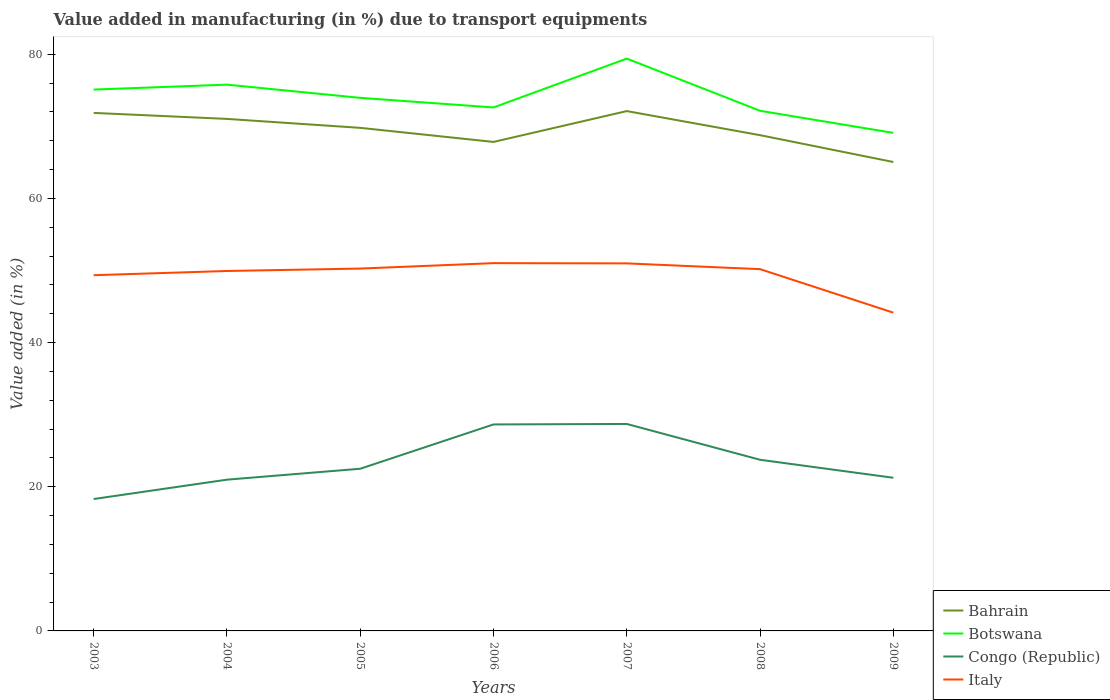Across all years, what is the maximum percentage of value added in manufacturing due to transport equipments in Bahrain?
Offer a terse response. 65.05. What is the total percentage of value added in manufacturing due to transport equipments in Botswana in the graph?
Offer a very short reply. 1.15. What is the difference between the highest and the second highest percentage of value added in manufacturing due to transport equipments in Italy?
Your response must be concise. 6.87. How many years are there in the graph?
Offer a very short reply. 7. Where does the legend appear in the graph?
Provide a short and direct response. Bottom right. How are the legend labels stacked?
Your response must be concise. Vertical. What is the title of the graph?
Provide a short and direct response. Value added in manufacturing (in %) due to transport equipments. What is the label or title of the X-axis?
Your answer should be very brief. Years. What is the label or title of the Y-axis?
Your answer should be very brief. Value added (in %). What is the Value added (in %) in Bahrain in 2003?
Provide a succinct answer. 71.86. What is the Value added (in %) in Botswana in 2003?
Provide a short and direct response. 75.1. What is the Value added (in %) in Congo (Republic) in 2003?
Offer a terse response. 18.3. What is the Value added (in %) of Italy in 2003?
Provide a succinct answer. 49.35. What is the Value added (in %) of Bahrain in 2004?
Your answer should be very brief. 71.03. What is the Value added (in %) in Botswana in 2004?
Your answer should be compact. 75.78. What is the Value added (in %) of Congo (Republic) in 2004?
Make the answer very short. 20.98. What is the Value added (in %) in Italy in 2004?
Give a very brief answer. 49.93. What is the Value added (in %) in Bahrain in 2005?
Your answer should be very brief. 69.79. What is the Value added (in %) in Botswana in 2005?
Ensure brevity in your answer.  73.95. What is the Value added (in %) in Congo (Republic) in 2005?
Make the answer very short. 22.5. What is the Value added (in %) of Italy in 2005?
Your answer should be very brief. 50.27. What is the Value added (in %) of Bahrain in 2006?
Make the answer very short. 67.84. What is the Value added (in %) of Botswana in 2006?
Your response must be concise. 72.62. What is the Value added (in %) of Congo (Republic) in 2006?
Provide a succinct answer. 28.64. What is the Value added (in %) of Italy in 2006?
Make the answer very short. 51.02. What is the Value added (in %) in Bahrain in 2007?
Provide a short and direct response. 72.11. What is the Value added (in %) of Botswana in 2007?
Offer a terse response. 79.39. What is the Value added (in %) in Congo (Republic) in 2007?
Offer a very short reply. 28.71. What is the Value added (in %) in Italy in 2007?
Your answer should be very brief. 50.99. What is the Value added (in %) in Bahrain in 2008?
Keep it short and to the point. 68.77. What is the Value added (in %) of Botswana in 2008?
Offer a terse response. 72.15. What is the Value added (in %) in Congo (Republic) in 2008?
Your answer should be very brief. 23.74. What is the Value added (in %) of Italy in 2008?
Provide a short and direct response. 50.19. What is the Value added (in %) in Bahrain in 2009?
Give a very brief answer. 65.05. What is the Value added (in %) in Botswana in 2009?
Your response must be concise. 69.09. What is the Value added (in %) in Congo (Republic) in 2009?
Your answer should be very brief. 21.24. What is the Value added (in %) in Italy in 2009?
Your response must be concise. 44.15. Across all years, what is the maximum Value added (in %) of Bahrain?
Keep it short and to the point. 72.11. Across all years, what is the maximum Value added (in %) in Botswana?
Offer a terse response. 79.39. Across all years, what is the maximum Value added (in %) of Congo (Republic)?
Your response must be concise. 28.71. Across all years, what is the maximum Value added (in %) in Italy?
Offer a terse response. 51.02. Across all years, what is the minimum Value added (in %) of Bahrain?
Your answer should be very brief. 65.05. Across all years, what is the minimum Value added (in %) in Botswana?
Make the answer very short. 69.09. Across all years, what is the minimum Value added (in %) in Congo (Republic)?
Make the answer very short. 18.3. Across all years, what is the minimum Value added (in %) in Italy?
Make the answer very short. 44.15. What is the total Value added (in %) of Bahrain in the graph?
Provide a succinct answer. 486.45. What is the total Value added (in %) of Botswana in the graph?
Your answer should be very brief. 518.08. What is the total Value added (in %) of Congo (Republic) in the graph?
Ensure brevity in your answer.  164.12. What is the total Value added (in %) in Italy in the graph?
Keep it short and to the point. 345.88. What is the difference between the Value added (in %) of Bahrain in 2003 and that in 2004?
Your answer should be compact. 0.83. What is the difference between the Value added (in %) of Botswana in 2003 and that in 2004?
Offer a very short reply. -0.68. What is the difference between the Value added (in %) in Congo (Republic) in 2003 and that in 2004?
Keep it short and to the point. -2.69. What is the difference between the Value added (in %) in Italy in 2003 and that in 2004?
Offer a very short reply. -0.58. What is the difference between the Value added (in %) in Bahrain in 2003 and that in 2005?
Provide a succinct answer. 2.07. What is the difference between the Value added (in %) of Botswana in 2003 and that in 2005?
Give a very brief answer. 1.15. What is the difference between the Value added (in %) in Congo (Republic) in 2003 and that in 2005?
Your response must be concise. -4.2. What is the difference between the Value added (in %) in Italy in 2003 and that in 2005?
Provide a succinct answer. -0.92. What is the difference between the Value added (in %) of Bahrain in 2003 and that in 2006?
Your answer should be compact. 4.03. What is the difference between the Value added (in %) in Botswana in 2003 and that in 2006?
Offer a terse response. 2.48. What is the difference between the Value added (in %) of Congo (Republic) in 2003 and that in 2006?
Provide a short and direct response. -10.35. What is the difference between the Value added (in %) of Italy in 2003 and that in 2006?
Keep it short and to the point. -1.67. What is the difference between the Value added (in %) of Bahrain in 2003 and that in 2007?
Offer a terse response. -0.25. What is the difference between the Value added (in %) of Botswana in 2003 and that in 2007?
Keep it short and to the point. -4.3. What is the difference between the Value added (in %) in Congo (Republic) in 2003 and that in 2007?
Offer a very short reply. -10.41. What is the difference between the Value added (in %) in Italy in 2003 and that in 2007?
Give a very brief answer. -1.64. What is the difference between the Value added (in %) of Bahrain in 2003 and that in 2008?
Your response must be concise. 3.09. What is the difference between the Value added (in %) in Botswana in 2003 and that in 2008?
Give a very brief answer. 2.94. What is the difference between the Value added (in %) of Congo (Republic) in 2003 and that in 2008?
Make the answer very short. -5.45. What is the difference between the Value added (in %) of Italy in 2003 and that in 2008?
Give a very brief answer. -0.84. What is the difference between the Value added (in %) of Bahrain in 2003 and that in 2009?
Provide a short and direct response. 6.81. What is the difference between the Value added (in %) in Botswana in 2003 and that in 2009?
Ensure brevity in your answer.  6.01. What is the difference between the Value added (in %) in Congo (Republic) in 2003 and that in 2009?
Offer a very short reply. -2.95. What is the difference between the Value added (in %) in Italy in 2003 and that in 2009?
Offer a very short reply. 5.2. What is the difference between the Value added (in %) of Bahrain in 2004 and that in 2005?
Offer a very short reply. 1.24. What is the difference between the Value added (in %) in Botswana in 2004 and that in 2005?
Offer a terse response. 1.83. What is the difference between the Value added (in %) of Congo (Republic) in 2004 and that in 2005?
Give a very brief answer. -1.51. What is the difference between the Value added (in %) of Italy in 2004 and that in 2005?
Your answer should be very brief. -0.33. What is the difference between the Value added (in %) of Bahrain in 2004 and that in 2006?
Your answer should be compact. 3.19. What is the difference between the Value added (in %) of Botswana in 2004 and that in 2006?
Your answer should be very brief. 3.17. What is the difference between the Value added (in %) in Congo (Republic) in 2004 and that in 2006?
Offer a terse response. -7.66. What is the difference between the Value added (in %) of Italy in 2004 and that in 2006?
Your response must be concise. -1.09. What is the difference between the Value added (in %) in Bahrain in 2004 and that in 2007?
Your answer should be compact. -1.08. What is the difference between the Value added (in %) in Botswana in 2004 and that in 2007?
Keep it short and to the point. -3.61. What is the difference between the Value added (in %) in Congo (Republic) in 2004 and that in 2007?
Provide a short and direct response. -7.73. What is the difference between the Value added (in %) in Italy in 2004 and that in 2007?
Your answer should be very brief. -1.05. What is the difference between the Value added (in %) in Bahrain in 2004 and that in 2008?
Your response must be concise. 2.26. What is the difference between the Value added (in %) of Botswana in 2004 and that in 2008?
Give a very brief answer. 3.63. What is the difference between the Value added (in %) of Congo (Republic) in 2004 and that in 2008?
Provide a succinct answer. -2.76. What is the difference between the Value added (in %) of Italy in 2004 and that in 2008?
Provide a succinct answer. -0.25. What is the difference between the Value added (in %) of Bahrain in 2004 and that in 2009?
Your answer should be compact. 5.98. What is the difference between the Value added (in %) in Botswana in 2004 and that in 2009?
Make the answer very short. 6.69. What is the difference between the Value added (in %) of Congo (Republic) in 2004 and that in 2009?
Provide a short and direct response. -0.26. What is the difference between the Value added (in %) of Italy in 2004 and that in 2009?
Your response must be concise. 5.78. What is the difference between the Value added (in %) of Bahrain in 2005 and that in 2006?
Give a very brief answer. 1.95. What is the difference between the Value added (in %) in Botswana in 2005 and that in 2006?
Provide a short and direct response. 1.33. What is the difference between the Value added (in %) in Congo (Republic) in 2005 and that in 2006?
Offer a very short reply. -6.15. What is the difference between the Value added (in %) in Italy in 2005 and that in 2006?
Offer a very short reply. -0.75. What is the difference between the Value added (in %) in Bahrain in 2005 and that in 2007?
Keep it short and to the point. -2.33. What is the difference between the Value added (in %) of Botswana in 2005 and that in 2007?
Your answer should be very brief. -5.45. What is the difference between the Value added (in %) in Congo (Republic) in 2005 and that in 2007?
Your response must be concise. -6.21. What is the difference between the Value added (in %) of Italy in 2005 and that in 2007?
Offer a terse response. -0.72. What is the difference between the Value added (in %) in Bahrain in 2005 and that in 2008?
Provide a short and direct response. 1.02. What is the difference between the Value added (in %) in Botswana in 2005 and that in 2008?
Provide a succinct answer. 1.8. What is the difference between the Value added (in %) of Congo (Republic) in 2005 and that in 2008?
Provide a short and direct response. -1.25. What is the difference between the Value added (in %) in Italy in 2005 and that in 2008?
Give a very brief answer. 0.08. What is the difference between the Value added (in %) of Bahrain in 2005 and that in 2009?
Provide a succinct answer. 4.74. What is the difference between the Value added (in %) of Botswana in 2005 and that in 2009?
Offer a terse response. 4.86. What is the difference between the Value added (in %) of Congo (Republic) in 2005 and that in 2009?
Provide a short and direct response. 1.25. What is the difference between the Value added (in %) in Italy in 2005 and that in 2009?
Provide a succinct answer. 6.12. What is the difference between the Value added (in %) of Bahrain in 2006 and that in 2007?
Your answer should be very brief. -4.28. What is the difference between the Value added (in %) of Botswana in 2006 and that in 2007?
Keep it short and to the point. -6.78. What is the difference between the Value added (in %) of Congo (Republic) in 2006 and that in 2007?
Keep it short and to the point. -0.07. What is the difference between the Value added (in %) in Italy in 2006 and that in 2007?
Offer a terse response. 0.03. What is the difference between the Value added (in %) of Bahrain in 2006 and that in 2008?
Offer a very short reply. -0.94. What is the difference between the Value added (in %) in Botswana in 2006 and that in 2008?
Make the answer very short. 0.46. What is the difference between the Value added (in %) in Congo (Republic) in 2006 and that in 2008?
Offer a terse response. 4.9. What is the difference between the Value added (in %) in Italy in 2006 and that in 2008?
Give a very brief answer. 0.83. What is the difference between the Value added (in %) in Bahrain in 2006 and that in 2009?
Give a very brief answer. 2.79. What is the difference between the Value added (in %) in Botswana in 2006 and that in 2009?
Make the answer very short. 3.53. What is the difference between the Value added (in %) of Congo (Republic) in 2006 and that in 2009?
Provide a succinct answer. 7.4. What is the difference between the Value added (in %) in Italy in 2006 and that in 2009?
Offer a terse response. 6.87. What is the difference between the Value added (in %) in Bahrain in 2007 and that in 2008?
Your response must be concise. 3.34. What is the difference between the Value added (in %) of Botswana in 2007 and that in 2008?
Give a very brief answer. 7.24. What is the difference between the Value added (in %) of Congo (Republic) in 2007 and that in 2008?
Your response must be concise. 4.97. What is the difference between the Value added (in %) in Italy in 2007 and that in 2008?
Offer a terse response. 0.8. What is the difference between the Value added (in %) in Bahrain in 2007 and that in 2009?
Provide a short and direct response. 7.06. What is the difference between the Value added (in %) in Botswana in 2007 and that in 2009?
Your answer should be very brief. 10.31. What is the difference between the Value added (in %) of Congo (Republic) in 2007 and that in 2009?
Your response must be concise. 7.47. What is the difference between the Value added (in %) in Italy in 2007 and that in 2009?
Ensure brevity in your answer.  6.83. What is the difference between the Value added (in %) in Bahrain in 2008 and that in 2009?
Offer a terse response. 3.72. What is the difference between the Value added (in %) in Botswana in 2008 and that in 2009?
Your answer should be compact. 3.07. What is the difference between the Value added (in %) of Congo (Republic) in 2008 and that in 2009?
Offer a very short reply. 2.5. What is the difference between the Value added (in %) of Italy in 2008 and that in 2009?
Keep it short and to the point. 6.04. What is the difference between the Value added (in %) in Bahrain in 2003 and the Value added (in %) in Botswana in 2004?
Your answer should be very brief. -3.92. What is the difference between the Value added (in %) in Bahrain in 2003 and the Value added (in %) in Congo (Republic) in 2004?
Your response must be concise. 50.88. What is the difference between the Value added (in %) of Bahrain in 2003 and the Value added (in %) of Italy in 2004?
Your response must be concise. 21.93. What is the difference between the Value added (in %) in Botswana in 2003 and the Value added (in %) in Congo (Republic) in 2004?
Offer a very short reply. 54.12. What is the difference between the Value added (in %) of Botswana in 2003 and the Value added (in %) of Italy in 2004?
Ensure brevity in your answer.  25.17. What is the difference between the Value added (in %) of Congo (Republic) in 2003 and the Value added (in %) of Italy in 2004?
Offer a terse response. -31.63. What is the difference between the Value added (in %) of Bahrain in 2003 and the Value added (in %) of Botswana in 2005?
Keep it short and to the point. -2.09. What is the difference between the Value added (in %) in Bahrain in 2003 and the Value added (in %) in Congo (Republic) in 2005?
Keep it short and to the point. 49.36. What is the difference between the Value added (in %) in Bahrain in 2003 and the Value added (in %) in Italy in 2005?
Ensure brevity in your answer.  21.59. What is the difference between the Value added (in %) of Botswana in 2003 and the Value added (in %) of Congo (Republic) in 2005?
Ensure brevity in your answer.  52.6. What is the difference between the Value added (in %) of Botswana in 2003 and the Value added (in %) of Italy in 2005?
Provide a succinct answer. 24.83. What is the difference between the Value added (in %) in Congo (Republic) in 2003 and the Value added (in %) in Italy in 2005?
Provide a short and direct response. -31.97. What is the difference between the Value added (in %) in Bahrain in 2003 and the Value added (in %) in Botswana in 2006?
Your response must be concise. -0.76. What is the difference between the Value added (in %) of Bahrain in 2003 and the Value added (in %) of Congo (Republic) in 2006?
Your response must be concise. 43.22. What is the difference between the Value added (in %) in Bahrain in 2003 and the Value added (in %) in Italy in 2006?
Make the answer very short. 20.84. What is the difference between the Value added (in %) of Botswana in 2003 and the Value added (in %) of Congo (Republic) in 2006?
Your answer should be very brief. 46.45. What is the difference between the Value added (in %) of Botswana in 2003 and the Value added (in %) of Italy in 2006?
Offer a terse response. 24.08. What is the difference between the Value added (in %) of Congo (Republic) in 2003 and the Value added (in %) of Italy in 2006?
Give a very brief answer. -32.72. What is the difference between the Value added (in %) of Bahrain in 2003 and the Value added (in %) of Botswana in 2007?
Provide a succinct answer. -7.53. What is the difference between the Value added (in %) of Bahrain in 2003 and the Value added (in %) of Congo (Republic) in 2007?
Keep it short and to the point. 43.15. What is the difference between the Value added (in %) in Bahrain in 2003 and the Value added (in %) in Italy in 2007?
Give a very brief answer. 20.87. What is the difference between the Value added (in %) in Botswana in 2003 and the Value added (in %) in Congo (Republic) in 2007?
Your answer should be very brief. 46.39. What is the difference between the Value added (in %) of Botswana in 2003 and the Value added (in %) of Italy in 2007?
Make the answer very short. 24.11. What is the difference between the Value added (in %) in Congo (Republic) in 2003 and the Value added (in %) in Italy in 2007?
Keep it short and to the point. -32.69. What is the difference between the Value added (in %) in Bahrain in 2003 and the Value added (in %) in Botswana in 2008?
Keep it short and to the point. -0.29. What is the difference between the Value added (in %) in Bahrain in 2003 and the Value added (in %) in Congo (Republic) in 2008?
Keep it short and to the point. 48.12. What is the difference between the Value added (in %) of Bahrain in 2003 and the Value added (in %) of Italy in 2008?
Your answer should be very brief. 21.67. What is the difference between the Value added (in %) of Botswana in 2003 and the Value added (in %) of Congo (Republic) in 2008?
Keep it short and to the point. 51.36. What is the difference between the Value added (in %) of Botswana in 2003 and the Value added (in %) of Italy in 2008?
Provide a succinct answer. 24.91. What is the difference between the Value added (in %) in Congo (Republic) in 2003 and the Value added (in %) in Italy in 2008?
Offer a terse response. -31.89. What is the difference between the Value added (in %) in Bahrain in 2003 and the Value added (in %) in Botswana in 2009?
Your answer should be very brief. 2.77. What is the difference between the Value added (in %) of Bahrain in 2003 and the Value added (in %) of Congo (Republic) in 2009?
Provide a succinct answer. 50.62. What is the difference between the Value added (in %) in Bahrain in 2003 and the Value added (in %) in Italy in 2009?
Provide a succinct answer. 27.71. What is the difference between the Value added (in %) of Botswana in 2003 and the Value added (in %) of Congo (Republic) in 2009?
Make the answer very short. 53.85. What is the difference between the Value added (in %) in Botswana in 2003 and the Value added (in %) in Italy in 2009?
Your answer should be very brief. 30.95. What is the difference between the Value added (in %) of Congo (Republic) in 2003 and the Value added (in %) of Italy in 2009?
Ensure brevity in your answer.  -25.85. What is the difference between the Value added (in %) of Bahrain in 2004 and the Value added (in %) of Botswana in 2005?
Your answer should be compact. -2.92. What is the difference between the Value added (in %) of Bahrain in 2004 and the Value added (in %) of Congo (Republic) in 2005?
Your answer should be compact. 48.53. What is the difference between the Value added (in %) in Bahrain in 2004 and the Value added (in %) in Italy in 2005?
Your answer should be very brief. 20.76. What is the difference between the Value added (in %) of Botswana in 2004 and the Value added (in %) of Congo (Republic) in 2005?
Your response must be concise. 53.28. What is the difference between the Value added (in %) of Botswana in 2004 and the Value added (in %) of Italy in 2005?
Provide a short and direct response. 25.52. What is the difference between the Value added (in %) in Congo (Republic) in 2004 and the Value added (in %) in Italy in 2005?
Provide a succinct answer. -29.28. What is the difference between the Value added (in %) of Bahrain in 2004 and the Value added (in %) of Botswana in 2006?
Keep it short and to the point. -1.59. What is the difference between the Value added (in %) in Bahrain in 2004 and the Value added (in %) in Congo (Republic) in 2006?
Make the answer very short. 42.38. What is the difference between the Value added (in %) in Bahrain in 2004 and the Value added (in %) in Italy in 2006?
Ensure brevity in your answer.  20.01. What is the difference between the Value added (in %) of Botswana in 2004 and the Value added (in %) of Congo (Republic) in 2006?
Provide a succinct answer. 47.14. What is the difference between the Value added (in %) of Botswana in 2004 and the Value added (in %) of Italy in 2006?
Ensure brevity in your answer.  24.76. What is the difference between the Value added (in %) in Congo (Republic) in 2004 and the Value added (in %) in Italy in 2006?
Your response must be concise. -30.04. What is the difference between the Value added (in %) of Bahrain in 2004 and the Value added (in %) of Botswana in 2007?
Provide a short and direct response. -8.37. What is the difference between the Value added (in %) of Bahrain in 2004 and the Value added (in %) of Congo (Republic) in 2007?
Your answer should be compact. 42.32. What is the difference between the Value added (in %) in Bahrain in 2004 and the Value added (in %) in Italy in 2007?
Keep it short and to the point. 20.04. What is the difference between the Value added (in %) of Botswana in 2004 and the Value added (in %) of Congo (Republic) in 2007?
Ensure brevity in your answer.  47.07. What is the difference between the Value added (in %) of Botswana in 2004 and the Value added (in %) of Italy in 2007?
Offer a very short reply. 24.8. What is the difference between the Value added (in %) of Congo (Republic) in 2004 and the Value added (in %) of Italy in 2007?
Ensure brevity in your answer.  -30. What is the difference between the Value added (in %) in Bahrain in 2004 and the Value added (in %) in Botswana in 2008?
Make the answer very short. -1.13. What is the difference between the Value added (in %) in Bahrain in 2004 and the Value added (in %) in Congo (Republic) in 2008?
Ensure brevity in your answer.  47.29. What is the difference between the Value added (in %) in Bahrain in 2004 and the Value added (in %) in Italy in 2008?
Make the answer very short. 20.84. What is the difference between the Value added (in %) of Botswana in 2004 and the Value added (in %) of Congo (Republic) in 2008?
Offer a terse response. 52.04. What is the difference between the Value added (in %) in Botswana in 2004 and the Value added (in %) in Italy in 2008?
Provide a succinct answer. 25.6. What is the difference between the Value added (in %) in Congo (Republic) in 2004 and the Value added (in %) in Italy in 2008?
Offer a terse response. -29.2. What is the difference between the Value added (in %) of Bahrain in 2004 and the Value added (in %) of Botswana in 2009?
Make the answer very short. 1.94. What is the difference between the Value added (in %) of Bahrain in 2004 and the Value added (in %) of Congo (Republic) in 2009?
Give a very brief answer. 49.78. What is the difference between the Value added (in %) of Bahrain in 2004 and the Value added (in %) of Italy in 2009?
Ensure brevity in your answer.  26.88. What is the difference between the Value added (in %) of Botswana in 2004 and the Value added (in %) of Congo (Republic) in 2009?
Ensure brevity in your answer.  54.54. What is the difference between the Value added (in %) of Botswana in 2004 and the Value added (in %) of Italy in 2009?
Offer a terse response. 31.63. What is the difference between the Value added (in %) in Congo (Republic) in 2004 and the Value added (in %) in Italy in 2009?
Your answer should be compact. -23.17. What is the difference between the Value added (in %) of Bahrain in 2005 and the Value added (in %) of Botswana in 2006?
Give a very brief answer. -2.83. What is the difference between the Value added (in %) of Bahrain in 2005 and the Value added (in %) of Congo (Republic) in 2006?
Your answer should be compact. 41.14. What is the difference between the Value added (in %) in Bahrain in 2005 and the Value added (in %) in Italy in 2006?
Give a very brief answer. 18.77. What is the difference between the Value added (in %) of Botswana in 2005 and the Value added (in %) of Congo (Republic) in 2006?
Give a very brief answer. 45.3. What is the difference between the Value added (in %) of Botswana in 2005 and the Value added (in %) of Italy in 2006?
Ensure brevity in your answer.  22.93. What is the difference between the Value added (in %) of Congo (Republic) in 2005 and the Value added (in %) of Italy in 2006?
Keep it short and to the point. -28.52. What is the difference between the Value added (in %) of Bahrain in 2005 and the Value added (in %) of Botswana in 2007?
Ensure brevity in your answer.  -9.61. What is the difference between the Value added (in %) in Bahrain in 2005 and the Value added (in %) in Congo (Republic) in 2007?
Make the answer very short. 41.08. What is the difference between the Value added (in %) of Bahrain in 2005 and the Value added (in %) of Italy in 2007?
Ensure brevity in your answer.  18.8. What is the difference between the Value added (in %) of Botswana in 2005 and the Value added (in %) of Congo (Republic) in 2007?
Your answer should be compact. 45.24. What is the difference between the Value added (in %) in Botswana in 2005 and the Value added (in %) in Italy in 2007?
Your response must be concise. 22.96. What is the difference between the Value added (in %) in Congo (Republic) in 2005 and the Value added (in %) in Italy in 2007?
Your answer should be very brief. -28.49. What is the difference between the Value added (in %) of Bahrain in 2005 and the Value added (in %) of Botswana in 2008?
Provide a short and direct response. -2.37. What is the difference between the Value added (in %) in Bahrain in 2005 and the Value added (in %) in Congo (Republic) in 2008?
Provide a succinct answer. 46.04. What is the difference between the Value added (in %) in Bahrain in 2005 and the Value added (in %) in Italy in 2008?
Make the answer very short. 19.6. What is the difference between the Value added (in %) of Botswana in 2005 and the Value added (in %) of Congo (Republic) in 2008?
Offer a terse response. 50.21. What is the difference between the Value added (in %) in Botswana in 2005 and the Value added (in %) in Italy in 2008?
Make the answer very short. 23.76. What is the difference between the Value added (in %) in Congo (Republic) in 2005 and the Value added (in %) in Italy in 2008?
Offer a terse response. -27.69. What is the difference between the Value added (in %) in Bahrain in 2005 and the Value added (in %) in Botswana in 2009?
Give a very brief answer. 0.7. What is the difference between the Value added (in %) in Bahrain in 2005 and the Value added (in %) in Congo (Republic) in 2009?
Give a very brief answer. 48.54. What is the difference between the Value added (in %) in Bahrain in 2005 and the Value added (in %) in Italy in 2009?
Keep it short and to the point. 25.64. What is the difference between the Value added (in %) of Botswana in 2005 and the Value added (in %) of Congo (Republic) in 2009?
Your answer should be very brief. 52.7. What is the difference between the Value added (in %) of Botswana in 2005 and the Value added (in %) of Italy in 2009?
Make the answer very short. 29.8. What is the difference between the Value added (in %) in Congo (Republic) in 2005 and the Value added (in %) in Italy in 2009?
Offer a very short reply. -21.65. What is the difference between the Value added (in %) in Bahrain in 2006 and the Value added (in %) in Botswana in 2007?
Your answer should be compact. -11.56. What is the difference between the Value added (in %) in Bahrain in 2006 and the Value added (in %) in Congo (Republic) in 2007?
Your answer should be compact. 39.12. What is the difference between the Value added (in %) in Bahrain in 2006 and the Value added (in %) in Italy in 2007?
Offer a very short reply. 16.85. What is the difference between the Value added (in %) of Botswana in 2006 and the Value added (in %) of Congo (Republic) in 2007?
Ensure brevity in your answer.  43.91. What is the difference between the Value added (in %) of Botswana in 2006 and the Value added (in %) of Italy in 2007?
Your response must be concise. 21.63. What is the difference between the Value added (in %) of Congo (Republic) in 2006 and the Value added (in %) of Italy in 2007?
Ensure brevity in your answer.  -22.34. What is the difference between the Value added (in %) of Bahrain in 2006 and the Value added (in %) of Botswana in 2008?
Offer a very short reply. -4.32. What is the difference between the Value added (in %) of Bahrain in 2006 and the Value added (in %) of Congo (Republic) in 2008?
Provide a short and direct response. 44.09. What is the difference between the Value added (in %) in Bahrain in 2006 and the Value added (in %) in Italy in 2008?
Provide a succinct answer. 17.65. What is the difference between the Value added (in %) in Botswana in 2006 and the Value added (in %) in Congo (Republic) in 2008?
Provide a short and direct response. 48.87. What is the difference between the Value added (in %) in Botswana in 2006 and the Value added (in %) in Italy in 2008?
Offer a very short reply. 22.43. What is the difference between the Value added (in %) in Congo (Republic) in 2006 and the Value added (in %) in Italy in 2008?
Ensure brevity in your answer.  -21.54. What is the difference between the Value added (in %) of Bahrain in 2006 and the Value added (in %) of Botswana in 2009?
Your answer should be compact. -1.25. What is the difference between the Value added (in %) in Bahrain in 2006 and the Value added (in %) in Congo (Republic) in 2009?
Ensure brevity in your answer.  46.59. What is the difference between the Value added (in %) of Bahrain in 2006 and the Value added (in %) of Italy in 2009?
Provide a short and direct response. 23.68. What is the difference between the Value added (in %) in Botswana in 2006 and the Value added (in %) in Congo (Republic) in 2009?
Ensure brevity in your answer.  51.37. What is the difference between the Value added (in %) of Botswana in 2006 and the Value added (in %) of Italy in 2009?
Your response must be concise. 28.47. What is the difference between the Value added (in %) of Congo (Republic) in 2006 and the Value added (in %) of Italy in 2009?
Provide a succinct answer. -15.51. What is the difference between the Value added (in %) in Bahrain in 2007 and the Value added (in %) in Botswana in 2008?
Your answer should be very brief. -0.04. What is the difference between the Value added (in %) in Bahrain in 2007 and the Value added (in %) in Congo (Republic) in 2008?
Keep it short and to the point. 48.37. What is the difference between the Value added (in %) in Bahrain in 2007 and the Value added (in %) in Italy in 2008?
Ensure brevity in your answer.  21.93. What is the difference between the Value added (in %) of Botswana in 2007 and the Value added (in %) of Congo (Republic) in 2008?
Offer a terse response. 55.65. What is the difference between the Value added (in %) in Botswana in 2007 and the Value added (in %) in Italy in 2008?
Offer a very short reply. 29.21. What is the difference between the Value added (in %) in Congo (Republic) in 2007 and the Value added (in %) in Italy in 2008?
Ensure brevity in your answer.  -21.48. What is the difference between the Value added (in %) of Bahrain in 2007 and the Value added (in %) of Botswana in 2009?
Ensure brevity in your answer.  3.02. What is the difference between the Value added (in %) of Bahrain in 2007 and the Value added (in %) of Congo (Republic) in 2009?
Make the answer very short. 50.87. What is the difference between the Value added (in %) of Bahrain in 2007 and the Value added (in %) of Italy in 2009?
Keep it short and to the point. 27.96. What is the difference between the Value added (in %) of Botswana in 2007 and the Value added (in %) of Congo (Republic) in 2009?
Your response must be concise. 58.15. What is the difference between the Value added (in %) of Botswana in 2007 and the Value added (in %) of Italy in 2009?
Ensure brevity in your answer.  35.24. What is the difference between the Value added (in %) of Congo (Republic) in 2007 and the Value added (in %) of Italy in 2009?
Your answer should be very brief. -15.44. What is the difference between the Value added (in %) in Bahrain in 2008 and the Value added (in %) in Botswana in 2009?
Provide a succinct answer. -0.32. What is the difference between the Value added (in %) of Bahrain in 2008 and the Value added (in %) of Congo (Republic) in 2009?
Provide a short and direct response. 47.53. What is the difference between the Value added (in %) in Bahrain in 2008 and the Value added (in %) in Italy in 2009?
Your answer should be very brief. 24.62. What is the difference between the Value added (in %) of Botswana in 2008 and the Value added (in %) of Congo (Republic) in 2009?
Provide a short and direct response. 50.91. What is the difference between the Value added (in %) in Botswana in 2008 and the Value added (in %) in Italy in 2009?
Provide a short and direct response. 28. What is the difference between the Value added (in %) in Congo (Republic) in 2008 and the Value added (in %) in Italy in 2009?
Make the answer very short. -20.41. What is the average Value added (in %) of Bahrain per year?
Your response must be concise. 69.49. What is the average Value added (in %) in Botswana per year?
Provide a short and direct response. 74.01. What is the average Value added (in %) in Congo (Republic) per year?
Your answer should be compact. 23.45. What is the average Value added (in %) in Italy per year?
Keep it short and to the point. 49.41. In the year 2003, what is the difference between the Value added (in %) of Bahrain and Value added (in %) of Botswana?
Your answer should be compact. -3.24. In the year 2003, what is the difference between the Value added (in %) in Bahrain and Value added (in %) in Congo (Republic)?
Give a very brief answer. 53.56. In the year 2003, what is the difference between the Value added (in %) of Bahrain and Value added (in %) of Italy?
Keep it short and to the point. 22.51. In the year 2003, what is the difference between the Value added (in %) in Botswana and Value added (in %) in Congo (Republic)?
Provide a succinct answer. 56.8. In the year 2003, what is the difference between the Value added (in %) of Botswana and Value added (in %) of Italy?
Make the answer very short. 25.75. In the year 2003, what is the difference between the Value added (in %) of Congo (Republic) and Value added (in %) of Italy?
Provide a short and direct response. -31.05. In the year 2004, what is the difference between the Value added (in %) in Bahrain and Value added (in %) in Botswana?
Offer a very short reply. -4.75. In the year 2004, what is the difference between the Value added (in %) of Bahrain and Value added (in %) of Congo (Republic)?
Offer a very short reply. 50.05. In the year 2004, what is the difference between the Value added (in %) in Bahrain and Value added (in %) in Italy?
Make the answer very short. 21.1. In the year 2004, what is the difference between the Value added (in %) in Botswana and Value added (in %) in Congo (Republic)?
Your answer should be very brief. 54.8. In the year 2004, what is the difference between the Value added (in %) in Botswana and Value added (in %) in Italy?
Provide a short and direct response. 25.85. In the year 2004, what is the difference between the Value added (in %) in Congo (Republic) and Value added (in %) in Italy?
Your response must be concise. -28.95. In the year 2005, what is the difference between the Value added (in %) of Bahrain and Value added (in %) of Botswana?
Provide a short and direct response. -4.16. In the year 2005, what is the difference between the Value added (in %) in Bahrain and Value added (in %) in Congo (Republic)?
Offer a terse response. 47.29. In the year 2005, what is the difference between the Value added (in %) of Bahrain and Value added (in %) of Italy?
Make the answer very short. 19.52. In the year 2005, what is the difference between the Value added (in %) of Botswana and Value added (in %) of Congo (Republic)?
Your answer should be very brief. 51.45. In the year 2005, what is the difference between the Value added (in %) in Botswana and Value added (in %) in Italy?
Make the answer very short. 23.68. In the year 2005, what is the difference between the Value added (in %) in Congo (Republic) and Value added (in %) in Italy?
Offer a terse response. -27.77. In the year 2006, what is the difference between the Value added (in %) of Bahrain and Value added (in %) of Botswana?
Your answer should be compact. -4.78. In the year 2006, what is the difference between the Value added (in %) of Bahrain and Value added (in %) of Congo (Republic)?
Keep it short and to the point. 39.19. In the year 2006, what is the difference between the Value added (in %) of Bahrain and Value added (in %) of Italy?
Offer a very short reply. 16.82. In the year 2006, what is the difference between the Value added (in %) in Botswana and Value added (in %) in Congo (Republic)?
Keep it short and to the point. 43.97. In the year 2006, what is the difference between the Value added (in %) in Botswana and Value added (in %) in Italy?
Offer a very short reply. 21.6. In the year 2006, what is the difference between the Value added (in %) in Congo (Republic) and Value added (in %) in Italy?
Your response must be concise. -22.37. In the year 2007, what is the difference between the Value added (in %) of Bahrain and Value added (in %) of Botswana?
Provide a succinct answer. -7.28. In the year 2007, what is the difference between the Value added (in %) in Bahrain and Value added (in %) in Congo (Republic)?
Your answer should be very brief. 43.4. In the year 2007, what is the difference between the Value added (in %) in Bahrain and Value added (in %) in Italy?
Make the answer very short. 21.13. In the year 2007, what is the difference between the Value added (in %) in Botswana and Value added (in %) in Congo (Republic)?
Offer a terse response. 50.68. In the year 2007, what is the difference between the Value added (in %) in Botswana and Value added (in %) in Italy?
Offer a terse response. 28.41. In the year 2007, what is the difference between the Value added (in %) in Congo (Republic) and Value added (in %) in Italy?
Ensure brevity in your answer.  -22.27. In the year 2008, what is the difference between the Value added (in %) in Bahrain and Value added (in %) in Botswana?
Ensure brevity in your answer.  -3.38. In the year 2008, what is the difference between the Value added (in %) of Bahrain and Value added (in %) of Congo (Republic)?
Your answer should be compact. 45.03. In the year 2008, what is the difference between the Value added (in %) in Bahrain and Value added (in %) in Italy?
Your answer should be compact. 18.59. In the year 2008, what is the difference between the Value added (in %) in Botswana and Value added (in %) in Congo (Republic)?
Offer a very short reply. 48.41. In the year 2008, what is the difference between the Value added (in %) of Botswana and Value added (in %) of Italy?
Provide a short and direct response. 21.97. In the year 2008, what is the difference between the Value added (in %) in Congo (Republic) and Value added (in %) in Italy?
Provide a short and direct response. -26.44. In the year 2009, what is the difference between the Value added (in %) of Bahrain and Value added (in %) of Botswana?
Offer a terse response. -4.04. In the year 2009, what is the difference between the Value added (in %) in Bahrain and Value added (in %) in Congo (Republic)?
Offer a very short reply. 43.8. In the year 2009, what is the difference between the Value added (in %) in Bahrain and Value added (in %) in Italy?
Your response must be concise. 20.9. In the year 2009, what is the difference between the Value added (in %) in Botswana and Value added (in %) in Congo (Republic)?
Give a very brief answer. 47.84. In the year 2009, what is the difference between the Value added (in %) of Botswana and Value added (in %) of Italy?
Your response must be concise. 24.94. In the year 2009, what is the difference between the Value added (in %) in Congo (Republic) and Value added (in %) in Italy?
Ensure brevity in your answer.  -22.91. What is the ratio of the Value added (in %) in Bahrain in 2003 to that in 2004?
Your answer should be very brief. 1.01. What is the ratio of the Value added (in %) in Congo (Republic) in 2003 to that in 2004?
Ensure brevity in your answer.  0.87. What is the ratio of the Value added (in %) in Italy in 2003 to that in 2004?
Make the answer very short. 0.99. What is the ratio of the Value added (in %) in Bahrain in 2003 to that in 2005?
Provide a short and direct response. 1.03. What is the ratio of the Value added (in %) in Botswana in 2003 to that in 2005?
Offer a terse response. 1.02. What is the ratio of the Value added (in %) in Congo (Republic) in 2003 to that in 2005?
Provide a succinct answer. 0.81. What is the ratio of the Value added (in %) of Italy in 2003 to that in 2005?
Give a very brief answer. 0.98. What is the ratio of the Value added (in %) of Bahrain in 2003 to that in 2006?
Ensure brevity in your answer.  1.06. What is the ratio of the Value added (in %) of Botswana in 2003 to that in 2006?
Ensure brevity in your answer.  1.03. What is the ratio of the Value added (in %) in Congo (Republic) in 2003 to that in 2006?
Your response must be concise. 0.64. What is the ratio of the Value added (in %) in Italy in 2003 to that in 2006?
Keep it short and to the point. 0.97. What is the ratio of the Value added (in %) of Botswana in 2003 to that in 2007?
Provide a short and direct response. 0.95. What is the ratio of the Value added (in %) in Congo (Republic) in 2003 to that in 2007?
Your answer should be very brief. 0.64. What is the ratio of the Value added (in %) in Italy in 2003 to that in 2007?
Offer a terse response. 0.97. What is the ratio of the Value added (in %) of Bahrain in 2003 to that in 2008?
Your answer should be compact. 1.04. What is the ratio of the Value added (in %) of Botswana in 2003 to that in 2008?
Your answer should be very brief. 1.04. What is the ratio of the Value added (in %) in Congo (Republic) in 2003 to that in 2008?
Make the answer very short. 0.77. What is the ratio of the Value added (in %) of Italy in 2003 to that in 2008?
Give a very brief answer. 0.98. What is the ratio of the Value added (in %) in Bahrain in 2003 to that in 2009?
Your answer should be very brief. 1.1. What is the ratio of the Value added (in %) in Botswana in 2003 to that in 2009?
Your answer should be very brief. 1.09. What is the ratio of the Value added (in %) of Congo (Republic) in 2003 to that in 2009?
Your answer should be compact. 0.86. What is the ratio of the Value added (in %) of Italy in 2003 to that in 2009?
Your answer should be compact. 1.12. What is the ratio of the Value added (in %) of Bahrain in 2004 to that in 2005?
Your answer should be compact. 1.02. What is the ratio of the Value added (in %) of Botswana in 2004 to that in 2005?
Keep it short and to the point. 1.02. What is the ratio of the Value added (in %) in Congo (Republic) in 2004 to that in 2005?
Your answer should be very brief. 0.93. What is the ratio of the Value added (in %) in Bahrain in 2004 to that in 2006?
Provide a short and direct response. 1.05. What is the ratio of the Value added (in %) in Botswana in 2004 to that in 2006?
Your answer should be very brief. 1.04. What is the ratio of the Value added (in %) of Congo (Republic) in 2004 to that in 2006?
Offer a very short reply. 0.73. What is the ratio of the Value added (in %) of Italy in 2004 to that in 2006?
Your response must be concise. 0.98. What is the ratio of the Value added (in %) in Botswana in 2004 to that in 2007?
Provide a short and direct response. 0.95. What is the ratio of the Value added (in %) of Congo (Republic) in 2004 to that in 2007?
Make the answer very short. 0.73. What is the ratio of the Value added (in %) in Italy in 2004 to that in 2007?
Offer a terse response. 0.98. What is the ratio of the Value added (in %) of Bahrain in 2004 to that in 2008?
Provide a short and direct response. 1.03. What is the ratio of the Value added (in %) in Botswana in 2004 to that in 2008?
Give a very brief answer. 1.05. What is the ratio of the Value added (in %) in Congo (Republic) in 2004 to that in 2008?
Offer a terse response. 0.88. What is the ratio of the Value added (in %) of Italy in 2004 to that in 2008?
Make the answer very short. 0.99. What is the ratio of the Value added (in %) in Bahrain in 2004 to that in 2009?
Offer a terse response. 1.09. What is the ratio of the Value added (in %) of Botswana in 2004 to that in 2009?
Provide a succinct answer. 1.1. What is the ratio of the Value added (in %) of Congo (Republic) in 2004 to that in 2009?
Give a very brief answer. 0.99. What is the ratio of the Value added (in %) of Italy in 2004 to that in 2009?
Provide a succinct answer. 1.13. What is the ratio of the Value added (in %) of Bahrain in 2005 to that in 2006?
Offer a very short reply. 1.03. What is the ratio of the Value added (in %) in Botswana in 2005 to that in 2006?
Your answer should be compact. 1.02. What is the ratio of the Value added (in %) in Congo (Republic) in 2005 to that in 2006?
Offer a very short reply. 0.79. What is the ratio of the Value added (in %) of Italy in 2005 to that in 2006?
Offer a terse response. 0.99. What is the ratio of the Value added (in %) in Botswana in 2005 to that in 2007?
Give a very brief answer. 0.93. What is the ratio of the Value added (in %) in Congo (Republic) in 2005 to that in 2007?
Provide a succinct answer. 0.78. What is the ratio of the Value added (in %) of Italy in 2005 to that in 2007?
Offer a terse response. 0.99. What is the ratio of the Value added (in %) in Bahrain in 2005 to that in 2008?
Give a very brief answer. 1.01. What is the ratio of the Value added (in %) in Botswana in 2005 to that in 2008?
Offer a very short reply. 1.02. What is the ratio of the Value added (in %) in Congo (Republic) in 2005 to that in 2008?
Your response must be concise. 0.95. What is the ratio of the Value added (in %) of Italy in 2005 to that in 2008?
Provide a succinct answer. 1. What is the ratio of the Value added (in %) in Bahrain in 2005 to that in 2009?
Your response must be concise. 1.07. What is the ratio of the Value added (in %) of Botswana in 2005 to that in 2009?
Ensure brevity in your answer.  1.07. What is the ratio of the Value added (in %) of Congo (Republic) in 2005 to that in 2009?
Provide a short and direct response. 1.06. What is the ratio of the Value added (in %) of Italy in 2005 to that in 2009?
Your answer should be very brief. 1.14. What is the ratio of the Value added (in %) of Bahrain in 2006 to that in 2007?
Provide a succinct answer. 0.94. What is the ratio of the Value added (in %) in Botswana in 2006 to that in 2007?
Provide a succinct answer. 0.91. What is the ratio of the Value added (in %) in Italy in 2006 to that in 2007?
Your answer should be very brief. 1. What is the ratio of the Value added (in %) in Bahrain in 2006 to that in 2008?
Provide a succinct answer. 0.99. What is the ratio of the Value added (in %) in Botswana in 2006 to that in 2008?
Your answer should be very brief. 1.01. What is the ratio of the Value added (in %) of Congo (Republic) in 2006 to that in 2008?
Your answer should be very brief. 1.21. What is the ratio of the Value added (in %) of Italy in 2006 to that in 2008?
Provide a short and direct response. 1.02. What is the ratio of the Value added (in %) in Bahrain in 2006 to that in 2009?
Your answer should be compact. 1.04. What is the ratio of the Value added (in %) of Botswana in 2006 to that in 2009?
Your answer should be compact. 1.05. What is the ratio of the Value added (in %) in Congo (Republic) in 2006 to that in 2009?
Give a very brief answer. 1.35. What is the ratio of the Value added (in %) in Italy in 2006 to that in 2009?
Provide a short and direct response. 1.16. What is the ratio of the Value added (in %) in Bahrain in 2007 to that in 2008?
Ensure brevity in your answer.  1.05. What is the ratio of the Value added (in %) of Botswana in 2007 to that in 2008?
Give a very brief answer. 1.1. What is the ratio of the Value added (in %) of Congo (Republic) in 2007 to that in 2008?
Your answer should be very brief. 1.21. What is the ratio of the Value added (in %) in Italy in 2007 to that in 2008?
Your answer should be very brief. 1.02. What is the ratio of the Value added (in %) in Bahrain in 2007 to that in 2009?
Keep it short and to the point. 1.11. What is the ratio of the Value added (in %) of Botswana in 2007 to that in 2009?
Your response must be concise. 1.15. What is the ratio of the Value added (in %) of Congo (Republic) in 2007 to that in 2009?
Your answer should be very brief. 1.35. What is the ratio of the Value added (in %) in Italy in 2007 to that in 2009?
Offer a very short reply. 1.15. What is the ratio of the Value added (in %) in Bahrain in 2008 to that in 2009?
Give a very brief answer. 1.06. What is the ratio of the Value added (in %) in Botswana in 2008 to that in 2009?
Offer a very short reply. 1.04. What is the ratio of the Value added (in %) in Congo (Republic) in 2008 to that in 2009?
Keep it short and to the point. 1.12. What is the ratio of the Value added (in %) of Italy in 2008 to that in 2009?
Your response must be concise. 1.14. What is the difference between the highest and the second highest Value added (in %) in Bahrain?
Give a very brief answer. 0.25. What is the difference between the highest and the second highest Value added (in %) of Botswana?
Keep it short and to the point. 3.61. What is the difference between the highest and the second highest Value added (in %) of Congo (Republic)?
Your answer should be very brief. 0.07. What is the difference between the highest and the second highest Value added (in %) of Italy?
Offer a terse response. 0.03. What is the difference between the highest and the lowest Value added (in %) in Bahrain?
Your answer should be very brief. 7.06. What is the difference between the highest and the lowest Value added (in %) of Botswana?
Offer a terse response. 10.31. What is the difference between the highest and the lowest Value added (in %) of Congo (Republic)?
Make the answer very short. 10.41. What is the difference between the highest and the lowest Value added (in %) of Italy?
Offer a very short reply. 6.87. 